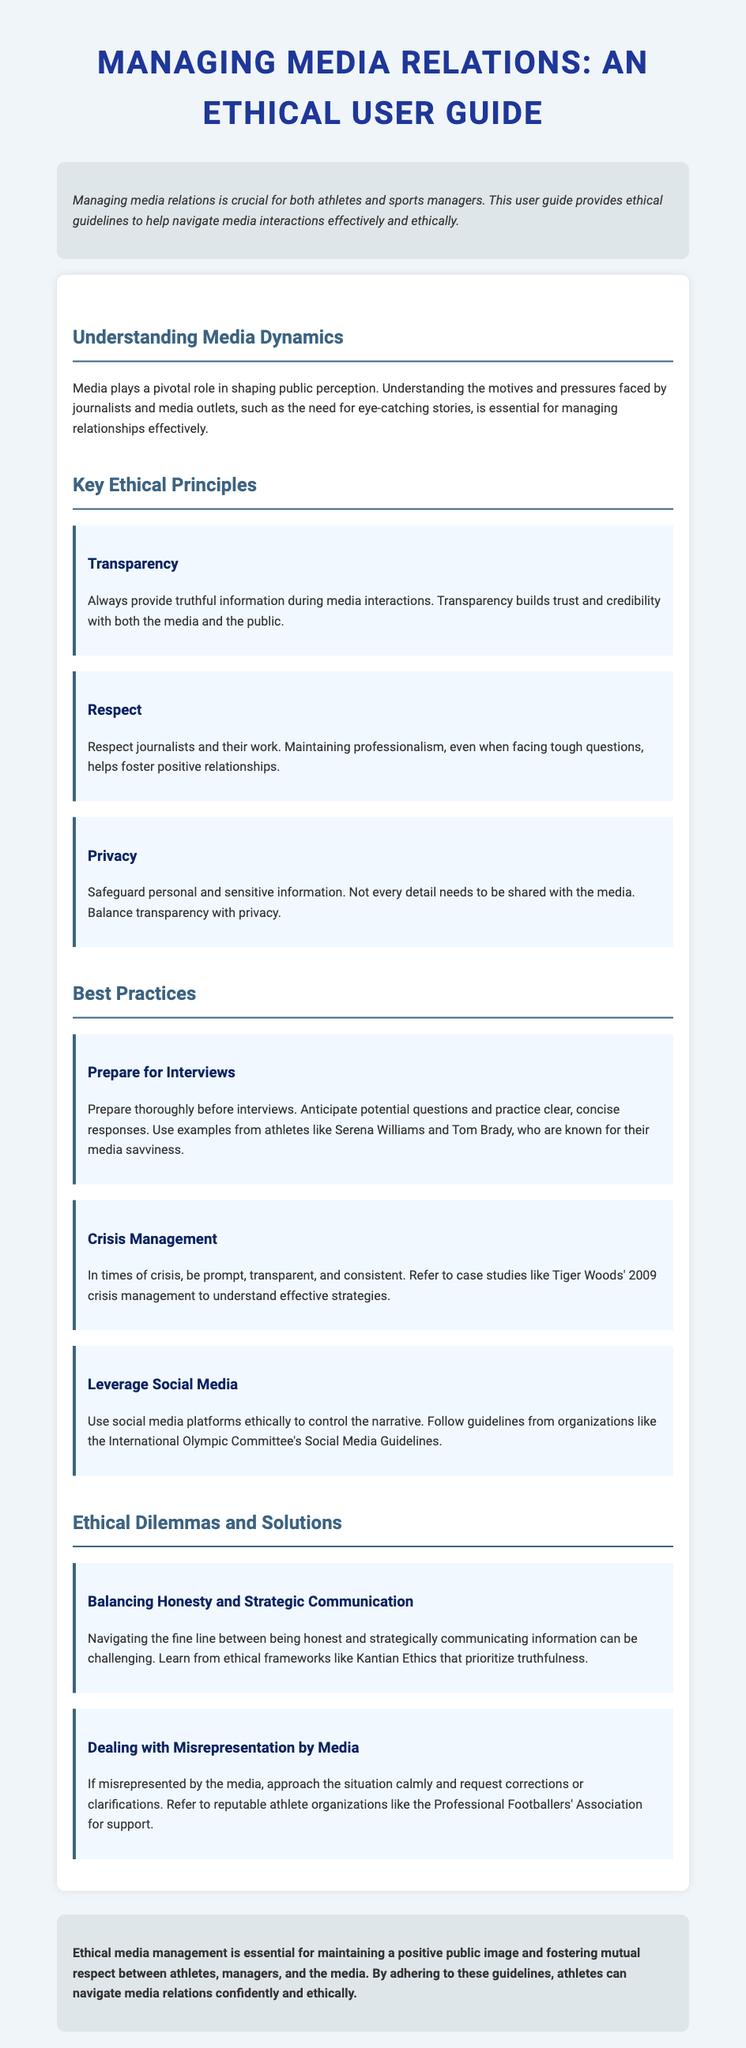What is the title of the guide? The title of the guide is provided in the header section of the document.
Answer: Managing Media Relations: An Ethical User Guide What principle emphasizes building trust and credibility? The principles are listed in the Key Ethical Principles section.
Answer: Transparency What should athletes prepare before interviews? The Best Practices section outlines specific actions athletes should take before interviews.
Answer: Thoroughly Which athlete is mentioned as an example of media savviness? The document provides an example of an athlete known for their interaction with the media.
Answer: Serena Williams What section addresses navigating honesty and strategic communication? The Ethical Dilemmas and Solutions section discusses this issue.
Answer: Balancing Honesty and Strategic Communication What organization is referenced for support against media misrepresentation? The document cites organizations that provide assistance in dealing with misrepresentation.
Answer: Professional Footballers' Association What does ethical media management foster between athletes and media? The conclusion discusses the outcome of adhering to ethical guidelines in media relations.
Answer: Mutual respect Which ethical framework is mentioned regarding truthfulness? The Ethical Dilemmas and Solutions section references a specific ethical framework.
Answer: Kantian Ethics What role does media play according to the document? The Introduction and Understanding Media Dynamics sections highlight the media's influence.
Answer: Shaping public perception 